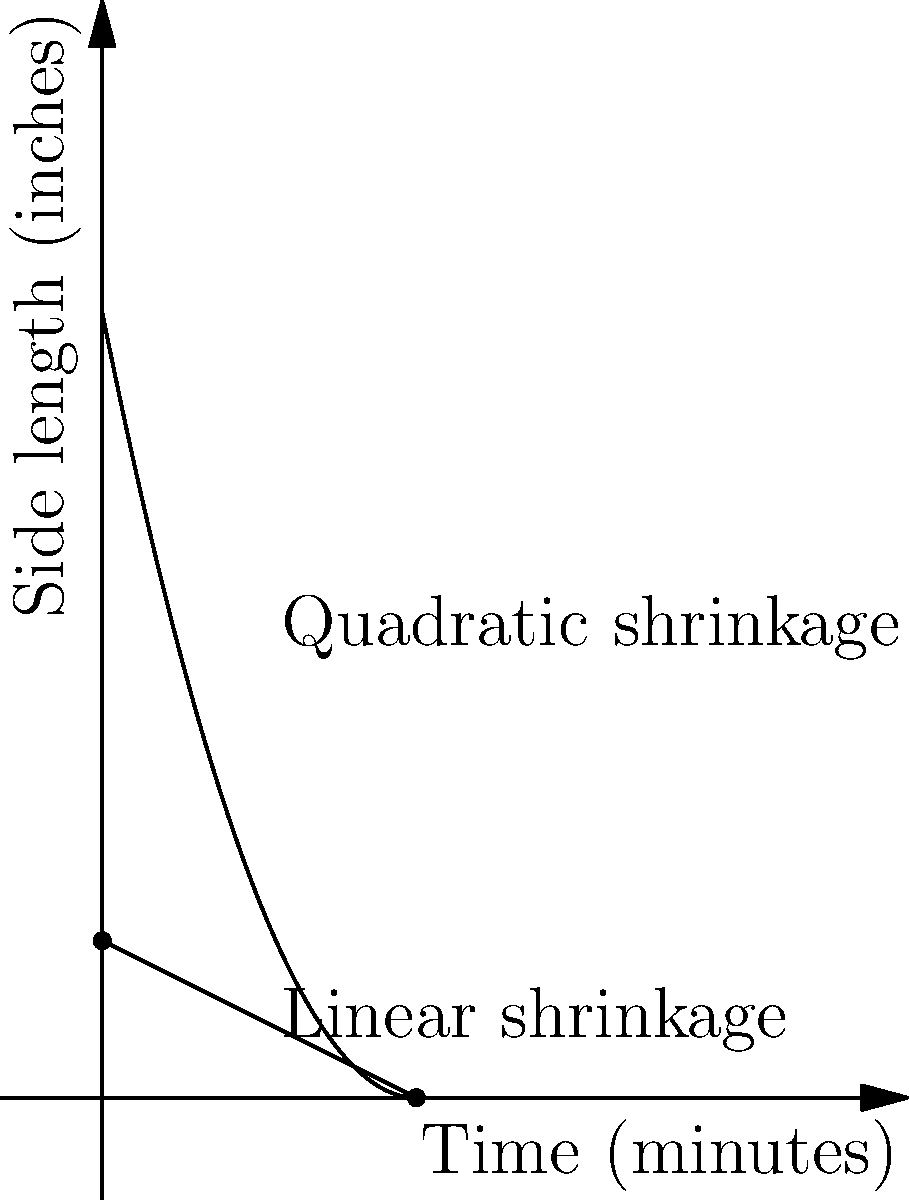At Whataburger, the square patties start with a side length of 5 inches. During cooking, the side length $s$ (in inches) shrinks according to the function $s(t) = 5 - 0.5t + 0.025t^2$, where $t$ is the cooking time in minutes. Calculate the rate at which the surface area of the patty is changing after 4 minutes of cooking. Let's approach this step-by-step:

1) The surface area $A$ of a square is given by $A = s^2$, where $s$ is the side length.

2) We're given that $s(t) = 5 - 0.5t + 0.025t^2$

3) To find the rate of change of the surface area, we need to find $\frac{dA}{dt}$

4) Using the chain rule:
   $$\frac{dA}{dt} = \frac{dA}{ds} \cdot \frac{ds}{dt}$$

5) We know that $\frac{dA}{ds} = 2s$ (derivative of $s^2$)

6) To find $\frac{ds}{dt}$, we differentiate $s(t)$:
   $$\frac{ds}{dt} = -0.5 + 0.05t$$

7) Substituting these into our chain rule equation:
   $$\frac{dA}{dt} = 2s \cdot (-0.5 + 0.05t)$$

8) Now, we need to evaluate this at $t = 4$ minutes. First, let's find $s(4)$:
   $$s(4) = 5 - 0.5(4) + 0.025(4^2) = 5 - 2 + 0.4 = 3.4$$

9) Now we can substitute everything into our equation:
   $$\frac{dA}{dt} = 2(3.4) \cdot (-0.5 + 0.05(4)) = 6.8 \cdot (-0.3) = -2.04$$

Therefore, after 4 minutes, the surface area is decreasing at a rate of 2.04 square inches per minute.
Answer: $-2.04$ square inches per minute 